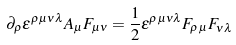<formula> <loc_0><loc_0><loc_500><loc_500>\partial _ { \rho } \epsilon ^ { \rho \mu \nu \lambda } A _ { \mu } F _ { \mu \nu } = \frac { 1 } { 2 } \epsilon ^ { \rho \mu \nu \lambda } F _ { \rho \mu } F _ { \nu \lambda }</formula> 